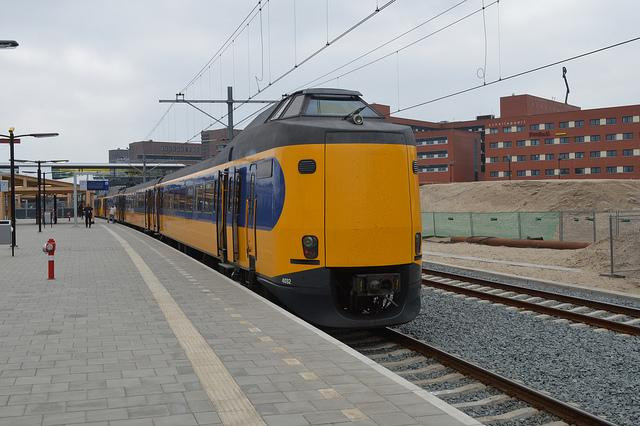What substance can be obtained from the red object?

Choices:
A) juice
B) oil
C) water
D) fire water 